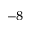<formula> <loc_0><loc_0><loc_500><loc_500>^ { - 8 }</formula> 